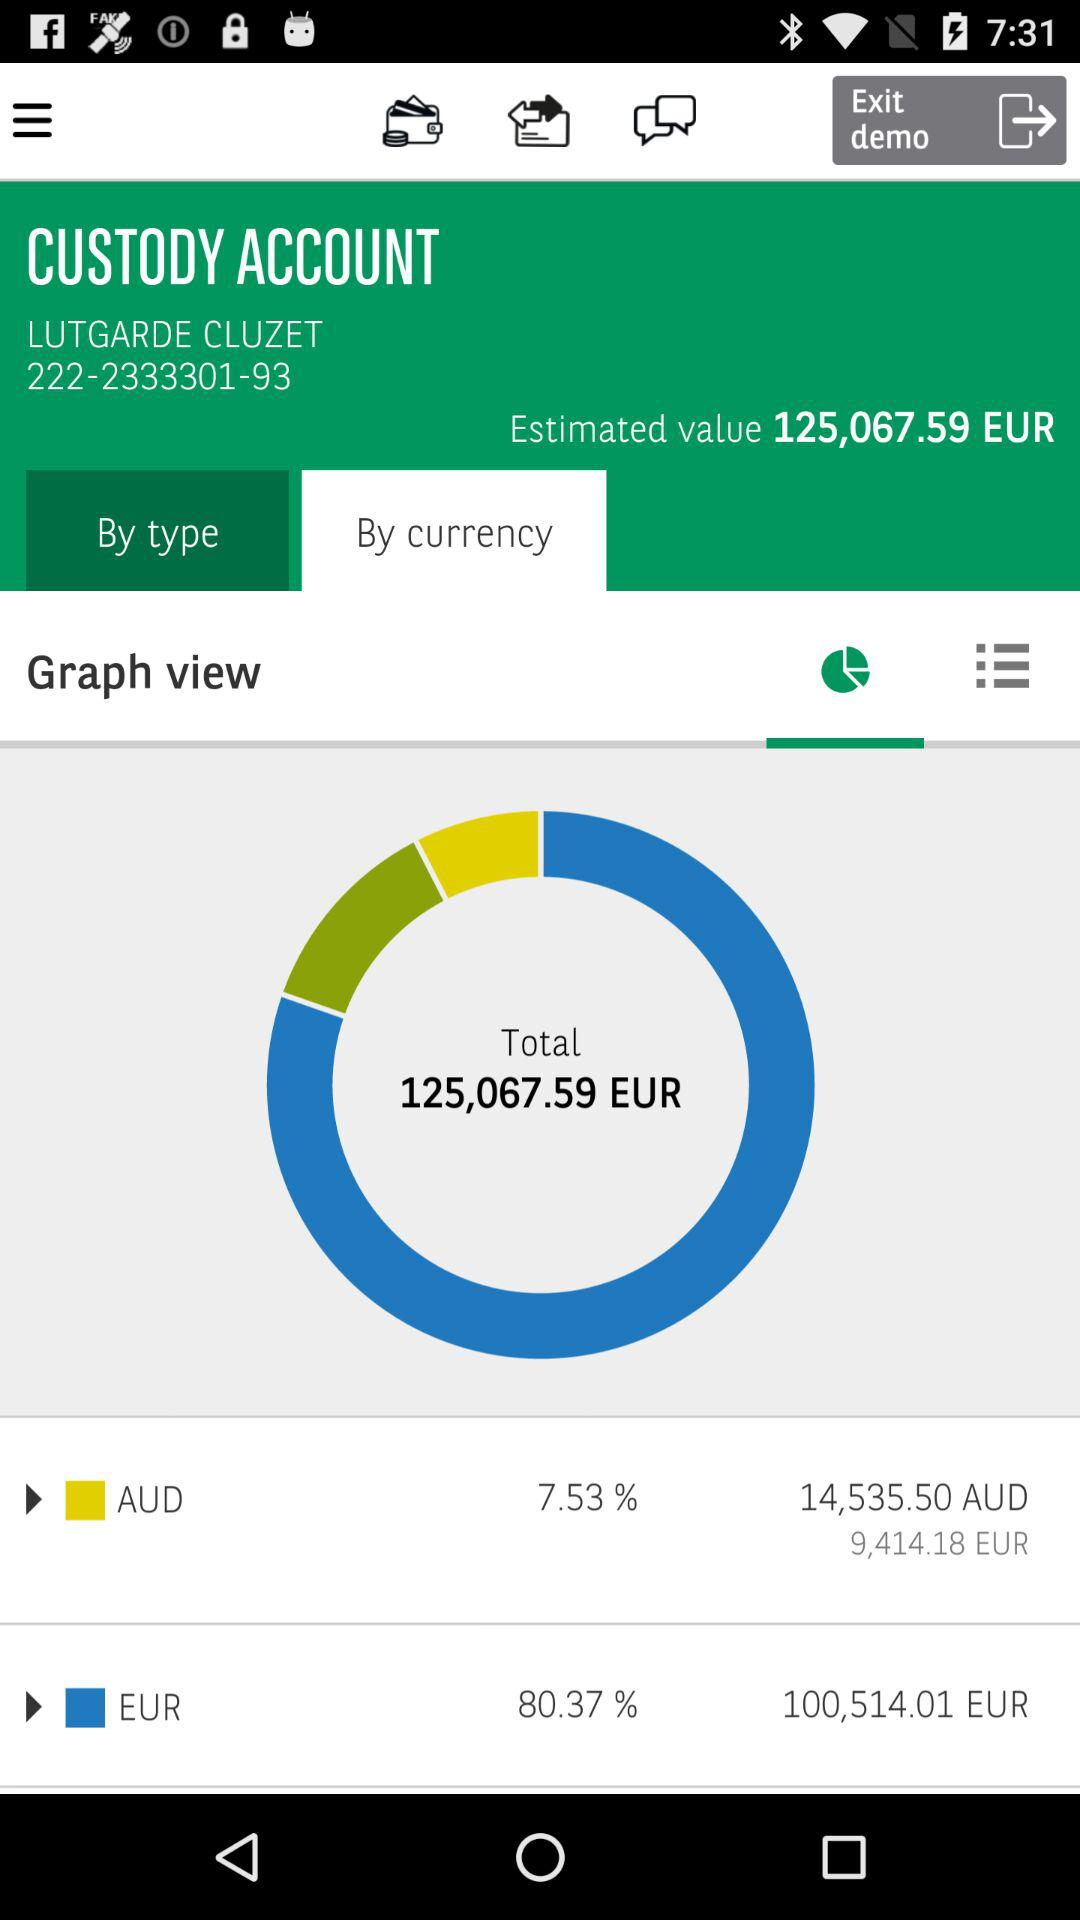What is Lutgarde Cluzet's account number? Lutgarde Cluzet's account number is 222-2333301-93. 